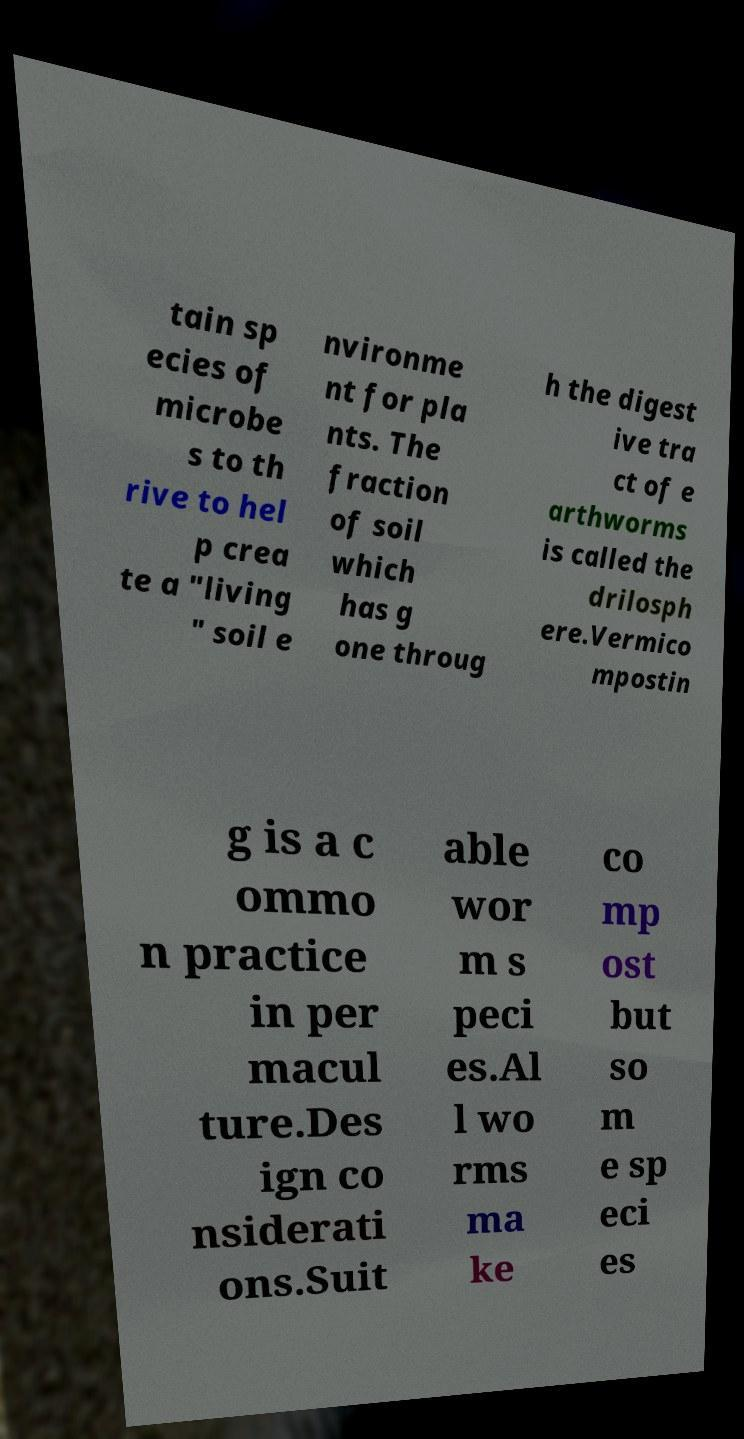I need the written content from this picture converted into text. Can you do that? tain sp ecies of microbe s to th rive to hel p crea te a "living " soil e nvironme nt for pla nts. The fraction of soil which has g one throug h the digest ive tra ct of e arthworms is called the drilosph ere.Vermico mpostin g is a c ommo n practice in per macul ture.Des ign co nsiderati ons.Suit able wor m s peci es.Al l wo rms ma ke co mp ost but so m e sp eci es 